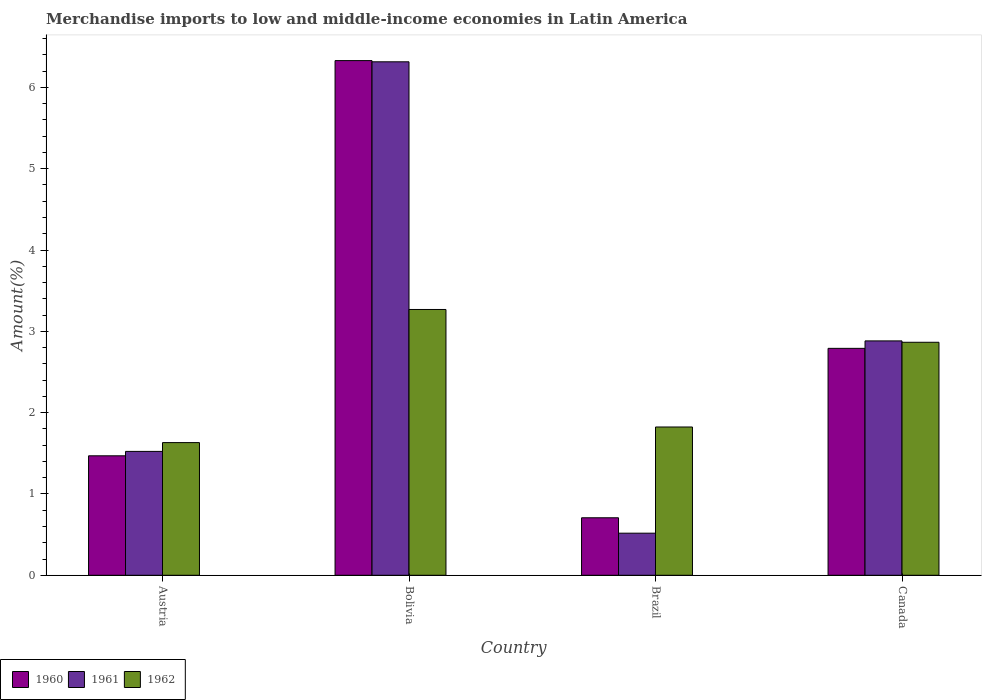Are the number of bars on each tick of the X-axis equal?
Your response must be concise. Yes. How many bars are there on the 2nd tick from the left?
Ensure brevity in your answer.  3. In how many cases, is the number of bars for a given country not equal to the number of legend labels?
Offer a very short reply. 0. What is the percentage of amount earned from merchandise imports in 1961 in Canada?
Keep it short and to the point. 2.88. Across all countries, what is the maximum percentage of amount earned from merchandise imports in 1961?
Offer a terse response. 6.31. Across all countries, what is the minimum percentage of amount earned from merchandise imports in 1960?
Give a very brief answer. 0.71. What is the total percentage of amount earned from merchandise imports in 1962 in the graph?
Your answer should be compact. 9.59. What is the difference between the percentage of amount earned from merchandise imports in 1960 in Austria and that in Brazil?
Offer a terse response. 0.76. What is the difference between the percentage of amount earned from merchandise imports in 1960 in Austria and the percentage of amount earned from merchandise imports in 1962 in Bolivia?
Your answer should be very brief. -1.8. What is the average percentage of amount earned from merchandise imports in 1962 per country?
Your answer should be very brief. 2.4. What is the difference between the percentage of amount earned from merchandise imports of/in 1960 and percentage of amount earned from merchandise imports of/in 1962 in Brazil?
Give a very brief answer. -1.12. In how many countries, is the percentage of amount earned from merchandise imports in 1962 greater than 5.8 %?
Ensure brevity in your answer.  0. What is the ratio of the percentage of amount earned from merchandise imports in 1961 in Brazil to that in Canada?
Offer a terse response. 0.18. Is the percentage of amount earned from merchandise imports in 1960 in Brazil less than that in Canada?
Keep it short and to the point. Yes. Is the difference between the percentage of amount earned from merchandise imports in 1960 in Bolivia and Canada greater than the difference between the percentage of amount earned from merchandise imports in 1962 in Bolivia and Canada?
Give a very brief answer. Yes. What is the difference between the highest and the second highest percentage of amount earned from merchandise imports in 1961?
Offer a very short reply. -1.36. What is the difference between the highest and the lowest percentage of amount earned from merchandise imports in 1962?
Make the answer very short. 1.64. In how many countries, is the percentage of amount earned from merchandise imports in 1961 greater than the average percentage of amount earned from merchandise imports in 1961 taken over all countries?
Give a very brief answer. 2. What does the 1st bar from the left in Bolivia represents?
Make the answer very short. 1960. What does the 2nd bar from the right in Austria represents?
Offer a terse response. 1961. Are all the bars in the graph horizontal?
Your answer should be compact. No. What is the difference between two consecutive major ticks on the Y-axis?
Your response must be concise. 1. How many legend labels are there?
Provide a short and direct response. 3. What is the title of the graph?
Offer a very short reply. Merchandise imports to low and middle-income economies in Latin America. Does "1996" appear as one of the legend labels in the graph?
Provide a short and direct response. No. What is the label or title of the Y-axis?
Offer a very short reply. Amount(%). What is the Amount(%) of 1960 in Austria?
Offer a very short reply. 1.47. What is the Amount(%) of 1961 in Austria?
Offer a terse response. 1.52. What is the Amount(%) in 1962 in Austria?
Provide a short and direct response. 1.63. What is the Amount(%) in 1960 in Bolivia?
Offer a very short reply. 6.33. What is the Amount(%) in 1961 in Bolivia?
Your answer should be compact. 6.31. What is the Amount(%) of 1962 in Bolivia?
Offer a very short reply. 3.27. What is the Amount(%) of 1960 in Brazil?
Provide a succinct answer. 0.71. What is the Amount(%) of 1961 in Brazil?
Make the answer very short. 0.52. What is the Amount(%) of 1962 in Brazil?
Offer a very short reply. 1.82. What is the Amount(%) in 1960 in Canada?
Make the answer very short. 2.79. What is the Amount(%) of 1961 in Canada?
Keep it short and to the point. 2.88. What is the Amount(%) in 1962 in Canada?
Provide a succinct answer. 2.87. Across all countries, what is the maximum Amount(%) in 1960?
Your response must be concise. 6.33. Across all countries, what is the maximum Amount(%) in 1961?
Provide a short and direct response. 6.31. Across all countries, what is the maximum Amount(%) of 1962?
Offer a terse response. 3.27. Across all countries, what is the minimum Amount(%) in 1960?
Your response must be concise. 0.71. Across all countries, what is the minimum Amount(%) of 1961?
Your answer should be compact. 0.52. Across all countries, what is the minimum Amount(%) in 1962?
Make the answer very short. 1.63. What is the total Amount(%) of 1960 in the graph?
Make the answer very short. 11.3. What is the total Amount(%) of 1961 in the graph?
Make the answer very short. 11.24. What is the total Amount(%) of 1962 in the graph?
Keep it short and to the point. 9.59. What is the difference between the Amount(%) in 1960 in Austria and that in Bolivia?
Offer a very short reply. -4.86. What is the difference between the Amount(%) of 1961 in Austria and that in Bolivia?
Provide a short and direct response. -4.79. What is the difference between the Amount(%) in 1962 in Austria and that in Bolivia?
Provide a short and direct response. -1.64. What is the difference between the Amount(%) in 1960 in Austria and that in Brazil?
Offer a terse response. 0.76. What is the difference between the Amount(%) of 1961 in Austria and that in Brazil?
Provide a succinct answer. 1.01. What is the difference between the Amount(%) in 1962 in Austria and that in Brazil?
Give a very brief answer. -0.19. What is the difference between the Amount(%) in 1960 in Austria and that in Canada?
Your answer should be compact. -1.32. What is the difference between the Amount(%) of 1961 in Austria and that in Canada?
Ensure brevity in your answer.  -1.36. What is the difference between the Amount(%) of 1962 in Austria and that in Canada?
Your answer should be very brief. -1.23. What is the difference between the Amount(%) of 1960 in Bolivia and that in Brazil?
Your response must be concise. 5.62. What is the difference between the Amount(%) of 1961 in Bolivia and that in Brazil?
Offer a very short reply. 5.8. What is the difference between the Amount(%) of 1962 in Bolivia and that in Brazil?
Provide a succinct answer. 1.45. What is the difference between the Amount(%) of 1960 in Bolivia and that in Canada?
Your answer should be very brief. 3.54. What is the difference between the Amount(%) in 1961 in Bolivia and that in Canada?
Your answer should be very brief. 3.43. What is the difference between the Amount(%) of 1962 in Bolivia and that in Canada?
Give a very brief answer. 0.4. What is the difference between the Amount(%) of 1960 in Brazil and that in Canada?
Provide a succinct answer. -2.08. What is the difference between the Amount(%) in 1961 in Brazil and that in Canada?
Provide a succinct answer. -2.36. What is the difference between the Amount(%) of 1962 in Brazil and that in Canada?
Make the answer very short. -1.04. What is the difference between the Amount(%) of 1960 in Austria and the Amount(%) of 1961 in Bolivia?
Provide a succinct answer. -4.85. What is the difference between the Amount(%) of 1960 in Austria and the Amount(%) of 1962 in Bolivia?
Provide a short and direct response. -1.8. What is the difference between the Amount(%) in 1961 in Austria and the Amount(%) in 1962 in Bolivia?
Your response must be concise. -1.75. What is the difference between the Amount(%) of 1960 in Austria and the Amount(%) of 1961 in Brazil?
Your response must be concise. 0.95. What is the difference between the Amount(%) in 1960 in Austria and the Amount(%) in 1962 in Brazil?
Provide a short and direct response. -0.35. What is the difference between the Amount(%) in 1961 in Austria and the Amount(%) in 1962 in Brazil?
Make the answer very short. -0.3. What is the difference between the Amount(%) of 1960 in Austria and the Amount(%) of 1961 in Canada?
Your response must be concise. -1.41. What is the difference between the Amount(%) of 1960 in Austria and the Amount(%) of 1962 in Canada?
Your answer should be compact. -1.4. What is the difference between the Amount(%) in 1961 in Austria and the Amount(%) in 1962 in Canada?
Provide a short and direct response. -1.34. What is the difference between the Amount(%) in 1960 in Bolivia and the Amount(%) in 1961 in Brazil?
Your answer should be compact. 5.81. What is the difference between the Amount(%) of 1960 in Bolivia and the Amount(%) of 1962 in Brazil?
Your answer should be compact. 4.51. What is the difference between the Amount(%) of 1961 in Bolivia and the Amount(%) of 1962 in Brazil?
Your answer should be very brief. 4.49. What is the difference between the Amount(%) in 1960 in Bolivia and the Amount(%) in 1961 in Canada?
Your answer should be compact. 3.45. What is the difference between the Amount(%) in 1960 in Bolivia and the Amount(%) in 1962 in Canada?
Offer a very short reply. 3.46. What is the difference between the Amount(%) of 1961 in Bolivia and the Amount(%) of 1962 in Canada?
Your answer should be very brief. 3.45. What is the difference between the Amount(%) of 1960 in Brazil and the Amount(%) of 1961 in Canada?
Ensure brevity in your answer.  -2.18. What is the difference between the Amount(%) in 1960 in Brazil and the Amount(%) in 1962 in Canada?
Provide a succinct answer. -2.16. What is the difference between the Amount(%) in 1961 in Brazil and the Amount(%) in 1962 in Canada?
Offer a very short reply. -2.35. What is the average Amount(%) of 1960 per country?
Your answer should be compact. 2.82. What is the average Amount(%) in 1961 per country?
Offer a very short reply. 2.81. What is the average Amount(%) in 1962 per country?
Give a very brief answer. 2.4. What is the difference between the Amount(%) in 1960 and Amount(%) in 1961 in Austria?
Your response must be concise. -0.05. What is the difference between the Amount(%) in 1960 and Amount(%) in 1962 in Austria?
Offer a very short reply. -0.16. What is the difference between the Amount(%) in 1961 and Amount(%) in 1962 in Austria?
Ensure brevity in your answer.  -0.11. What is the difference between the Amount(%) in 1960 and Amount(%) in 1961 in Bolivia?
Your response must be concise. 0.01. What is the difference between the Amount(%) in 1960 and Amount(%) in 1962 in Bolivia?
Make the answer very short. 3.06. What is the difference between the Amount(%) of 1961 and Amount(%) of 1962 in Bolivia?
Make the answer very short. 3.05. What is the difference between the Amount(%) in 1960 and Amount(%) in 1961 in Brazil?
Ensure brevity in your answer.  0.19. What is the difference between the Amount(%) of 1960 and Amount(%) of 1962 in Brazil?
Ensure brevity in your answer.  -1.12. What is the difference between the Amount(%) of 1961 and Amount(%) of 1962 in Brazil?
Provide a succinct answer. -1.31. What is the difference between the Amount(%) in 1960 and Amount(%) in 1961 in Canada?
Your response must be concise. -0.09. What is the difference between the Amount(%) of 1960 and Amount(%) of 1962 in Canada?
Keep it short and to the point. -0.07. What is the difference between the Amount(%) in 1961 and Amount(%) in 1962 in Canada?
Provide a short and direct response. 0.02. What is the ratio of the Amount(%) of 1960 in Austria to that in Bolivia?
Your answer should be compact. 0.23. What is the ratio of the Amount(%) of 1961 in Austria to that in Bolivia?
Provide a short and direct response. 0.24. What is the ratio of the Amount(%) of 1962 in Austria to that in Bolivia?
Provide a succinct answer. 0.5. What is the ratio of the Amount(%) in 1960 in Austria to that in Brazil?
Your answer should be compact. 2.08. What is the ratio of the Amount(%) in 1961 in Austria to that in Brazil?
Make the answer very short. 2.94. What is the ratio of the Amount(%) of 1962 in Austria to that in Brazil?
Give a very brief answer. 0.89. What is the ratio of the Amount(%) in 1960 in Austria to that in Canada?
Make the answer very short. 0.53. What is the ratio of the Amount(%) in 1961 in Austria to that in Canada?
Your answer should be very brief. 0.53. What is the ratio of the Amount(%) of 1962 in Austria to that in Canada?
Your answer should be compact. 0.57. What is the ratio of the Amount(%) in 1960 in Bolivia to that in Brazil?
Keep it short and to the point. 8.95. What is the ratio of the Amount(%) in 1961 in Bolivia to that in Brazil?
Ensure brevity in your answer.  12.2. What is the ratio of the Amount(%) of 1962 in Bolivia to that in Brazil?
Give a very brief answer. 1.79. What is the ratio of the Amount(%) in 1960 in Bolivia to that in Canada?
Provide a succinct answer. 2.27. What is the ratio of the Amount(%) in 1961 in Bolivia to that in Canada?
Make the answer very short. 2.19. What is the ratio of the Amount(%) in 1962 in Bolivia to that in Canada?
Your response must be concise. 1.14. What is the ratio of the Amount(%) of 1960 in Brazil to that in Canada?
Make the answer very short. 0.25. What is the ratio of the Amount(%) of 1961 in Brazil to that in Canada?
Provide a succinct answer. 0.18. What is the ratio of the Amount(%) in 1962 in Brazil to that in Canada?
Offer a very short reply. 0.64. What is the difference between the highest and the second highest Amount(%) of 1960?
Give a very brief answer. 3.54. What is the difference between the highest and the second highest Amount(%) in 1961?
Provide a short and direct response. 3.43. What is the difference between the highest and the second highest Amount(%) in 1962?
Ensure brevity in your answer.  0.4. What is the difference between the highest and the lowest Amount(%) of 1960?
Provide a succinct answer. 5.62. What is the difference between the highest and the lowest Amount(%) of 1961?
Ensure brevity in your answer.  5.8. What is the difference between the highest and the lowest Amount(%) in 1962?
Your answer should be very brief. 1.64. 